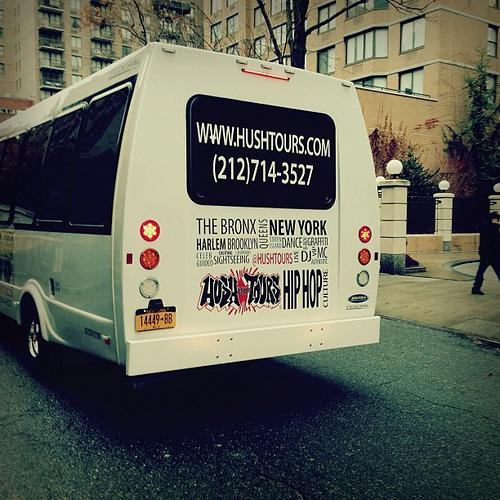Question: what website address?
Choices:
A. Www.hushtours.com.
B. www.google.com.
C. www.lmgtfy.com.
D. www.imgur.com.
Answer with the letter. Answer: A Question: what is the road color?
Choices:
A. Black.
B. Grey.
C. Brick red.
D. Yellow brick.
Answer with the letter. Answer: B Question: how many vans are there?
Choices:
A. 5.
B. 3.
C. 1.
D. 8.
Answer with the letter. Answer: C 